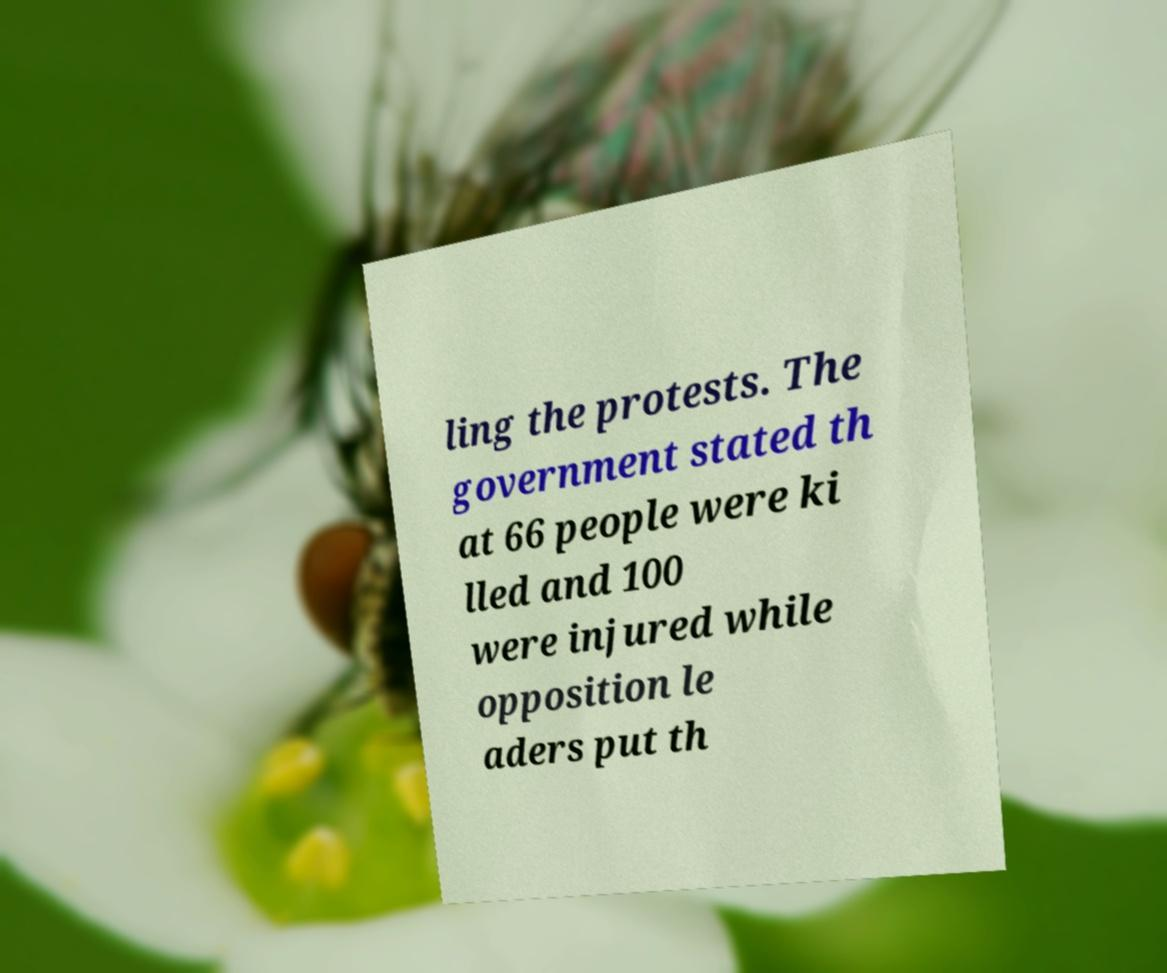Could you assist in decoding the text presented in this image and type it out clearly? ling the protests. The government stated th at 66 people were ki lled and 100 were injured while opposition le aders put th 